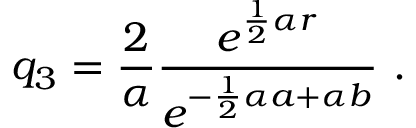Convert formula to latex. <formula><loc_0><loc_0><loc_500><loc_500>q _ { 3 } = \frac { 2 } { \alpha } \frac { e ^ { \frac { 1 } { 2 } \alpha r } } { e ^ { - \frac { 1 } { 2 } \alpha a + \alpha b } } \ .</formula> 